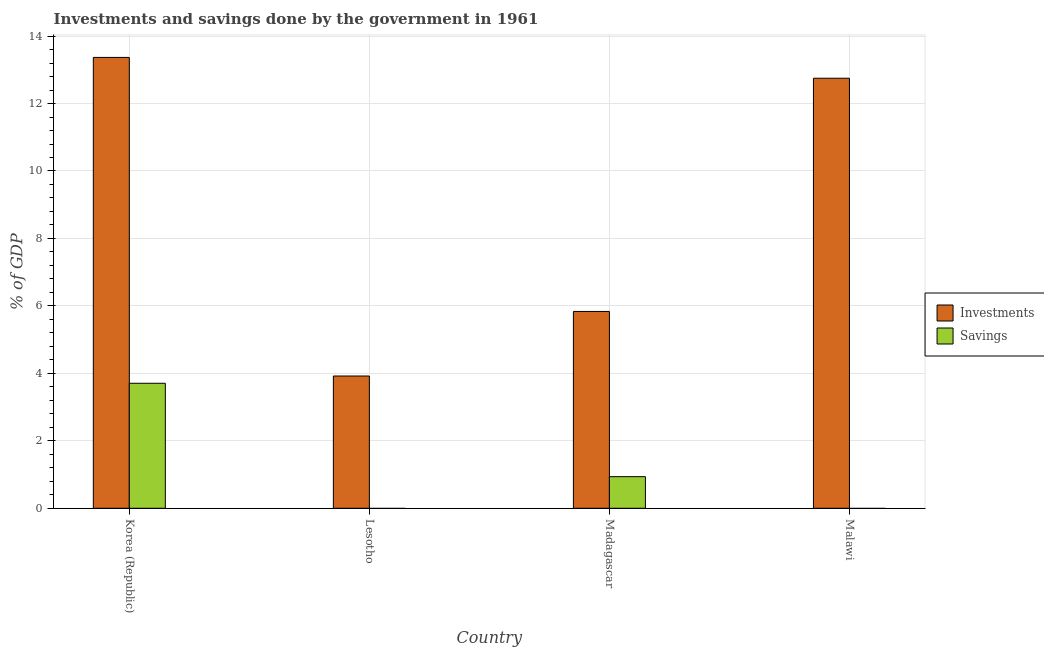How many different coloured bars are there?
Your response must be concise. 2. Are the number of bars per tick equal to the number of legend labels?
Provide a short and direct response. No. How many bars are there on the 1st tick from the left?
Your answer should be very brief. 2. What is the label of the 1st group of bars from the left?
Make the answer very short. Korea (Republic). In how many cases, is the number of bars for a given country not equal to the number of legend labels?
Your answer should be very brief. 2. Across all countries, what is the maximum investments of government?
Provide a short and direct response. 13.37. Across all countries, what is the minimum investments of government?
Keep it short and to the point. 3.92. What is the total investments of government in the graph?
Give a very brief answer. 35.88. What is the difference between the investments of government in Korea (Republic) and that in Madagascar?
Your answer should be very brief. 7.53. What is the difference between the savings of government in Madagascar and the investments of government in Malawi?
Your response must be concise. -11.81. What is the average investments of government per country?
Provide a succinct answer. 8.97. What is the difference between the investments of government and savings of government in Korea (Republic)?
Provide a short and direct response. 9.66. In how many countries, is the savings of government greater than 10.8 %?
Your answer should be very brief. 0. What is the ratio of the investments of government in Korea (Republic) to that in Malawi?
Ensure brevity in your answer.  1.05. What is the difference between the highest and the second highest investments of government?
Keep it short and to the point. 0.62. What is the difference between the highest and the lowest savings of government?
Keep it short and to the point. 3.71. How many bars are there?
Give a very brief answer. 6. How many countries are there in the graph?
Keep it short and to the point. 4. What is the difference between two consecutive major ticks on the Y-axis?
Provide a short and direct response. 2. Are the values on the major ticks of Y-axis written in scientific E-notation?
Give a very brief answer. No. Does the graph contain any zero values?
Offer a very short reply. Yes. What is the title of the graph?
Ensure brevity in your answer.  Investments and savings done by the government in 1961. What is the label or title of the X-axis?
Your answer should be compact. Country. What is the label or title of the Y-axis?
Give a very brief answer. % of GDP. What is the % of GDP in Investments in Korea (Republic)?
Your answer should be compact. 13.37. What is the % of GDP in Savings in Korea (Republic)?
Your response must be concise. 3.71. What is the % of GDP of Investments in Lesotho?
Offer a very short reply. 3.92. What is the % of GDP of Savings in Lesotho?
Provide a short and direct response. 0. What is the % of GDP in Investments in Madagascar?
Keep it short and to the point. 5.84. What is the % of GDP in Savings in Madagascar?
Provide a short and direct response. 0.94. What is the % of GDP of Investments in Malawi?
Provide a succinct answer. 12.75. What is the % of GDP of Savings in Malawi?
Your response must be concise. 0. Across all countries, what is the maximum % of GDP of Investments?
Offer a terse response. 13.37. Across all countries, what is the maximum % of GDP of Savings?
Give a very brief answer. 3.71. Across all countries, what is the minimum % of GDP of Investments?
Your response must be concise. 3.92. Across all countries, what is the minimum % of GDP in Savings?
Your answer should be compact. 0. What is the total % of GDP in Investments in the graph?
Your answer should be compact. 35.88. What is the total % of GDP in Savings in the graph?
Give a very brief answer. 4.64. What is the difference between the % of GDP of Investments in Korea (Republic) and that in Lesotho?
Provide a succinct answer. 9.45. What is the difference between the % of GDP of Investments in Korea (Republic) and that in Madagascar?
Provide a short and direct response. 7.53. What is the difference between the % of GDP of Savings in Korea (Republic) and that in Madagascar?
Offer a very short reply. 2.77. What is the difference between the % of GDP in Investments in Korea (Republic) and that in Malawi?
Your answer should be compact. 0.62. What is the difference between the % of GDP in Investments in Lesotho and that in Madagascar?
Offer a terse response. -1.91. What is the difference between the % of GDP in Investments in Lesotho and that in Malawi?
Make the answer very short. -8.83. What is the difference between the % of GDP in Investments in Madagascar and that in Malawi?
Provide a succinct answer. -6.92. What is the difference between the % of GDP of Investments in Korea (Republic) and the % of GDP of Savings in Madagascar?
Give a very brief answer. 12.43. What is the difference between the % of GDP in Investments in Lesotho and the % of GDP in Savings in Madagascar?
Your response must be concise. 2.98. What is the average % of GDP in Investments per country?
Keep it short and to the point. 8.97. What is the average % of GDP of Savings per country?
Give a very brief answer. 1.16. What is the difference between the % of GDP in Investments and % of GDP in Savings in Korea (Republic)?
Offer a very short reply. 9.66. What is the difference between the % of GDP of Investments and % of GDP of Savings in Madagascar?
Make the answer very short. 4.9. What is the ratio of the % of GDP of Investments in Korea (Republic) to that in Lesotho?
Ensure brevity in your answer.  3.41. What is the ratio of the % of GDP of Investments in Korea (Republic) to that in Madagascar?
Your response must be concise. 2.29. What is the ratio of the % of GDP in Savings in Korea (Republic) to that in Madagascar?
Provide a short and direct response. 3.96. What is the ratio of the % of GDP in Investments in Korea (Republic) to that in Malawi?
Give a very brief answer. 1.05. What is the ratio of the % of GDP in Investments in Lesotho to that in Madagascar?
Make the answer very short. 0.67. What is the ratio of the % of GDP of Investments in Lesotho to that in Malawi?
Give a very brief answer. 0.31. What is the ratio of the % of GDP in Investments in Madagascar to that in Malawi?
Keep it short and to the point. 0.46. What is the difference between the highest and the second highest % of GDP in Investments?
Your answer should be very brief. 0.62. What is the difference between the highest and the lowest % of GDP of Investments?
Offer a terse response. 9.45. What is the difference between the highest and the lowest % of GDP in Savings?
Your response must be concise. 3.71. 